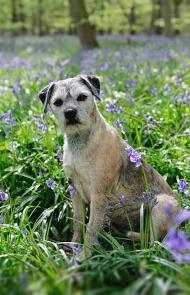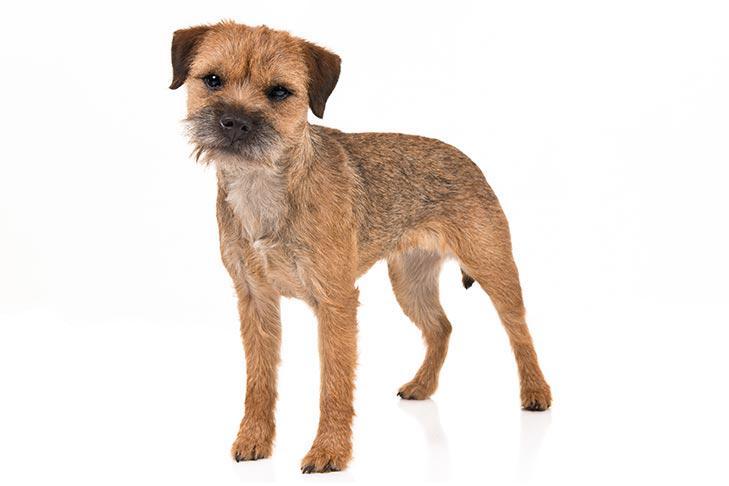The first image is the image on the left, the second image is the image on the right. Analyze the images presented: Is the assertion "One image includes a dog that is sitting upright, and the other image contains a single dog which is standing up." valid? Answer yes or no. Yes. The first image is the image on the left, the second image is the image on the right. For the images displayed, is the sentence "The left and right image contains the same number of dogs with at least one in the grass." factually correct? Answer yes or no. Yes. 